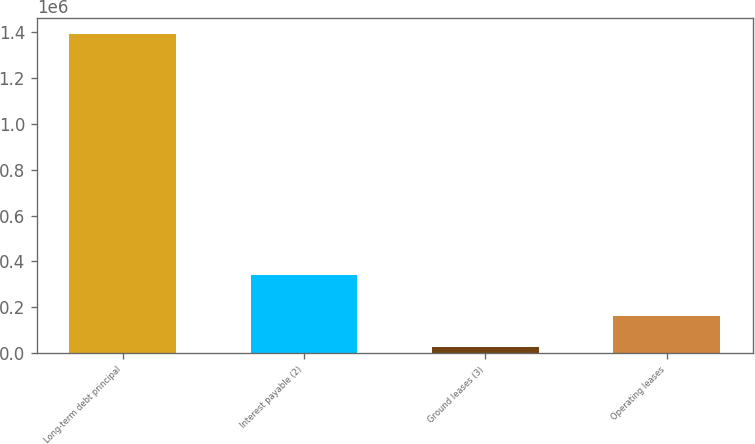Convert chart to OTSL. <chart><loc_0><loc_0><loc_500><loc_500><bar_chart><fcel>Long-term debt principal<fcel>Interest payable (2)<fcel>Ground leases (3)<fcel>Operating leases<nl><fcel>1.39322e+06<fcel>339869<fcel>26073<fcel>162788<nl></chart> 